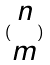<formula> <loc_0><loc_0><loc_500><loc_500>( \begin{matrix} n \\ m \end{matrix} )</formula> 